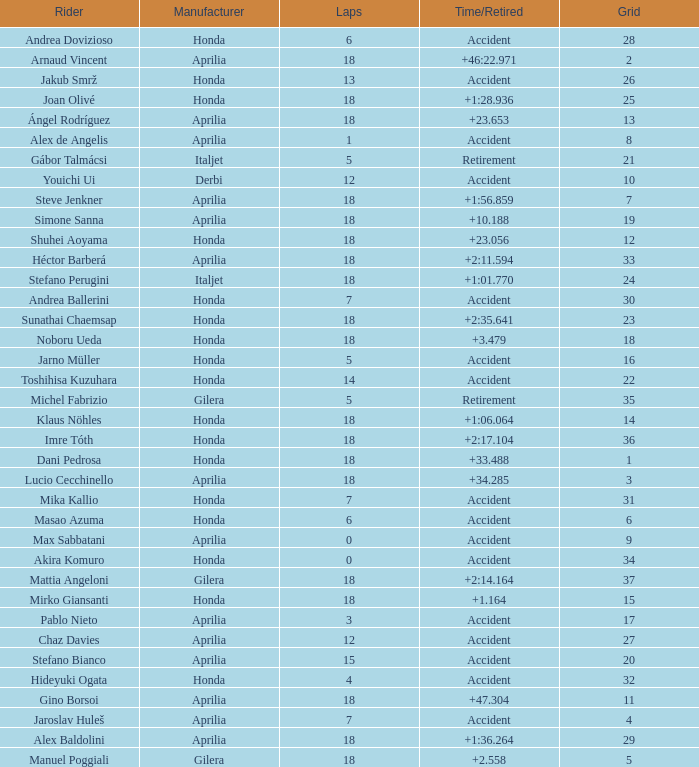Who is the rider with less than 15 laps, more than 32 grids, and an accident time/retired? Akira Komuro. 